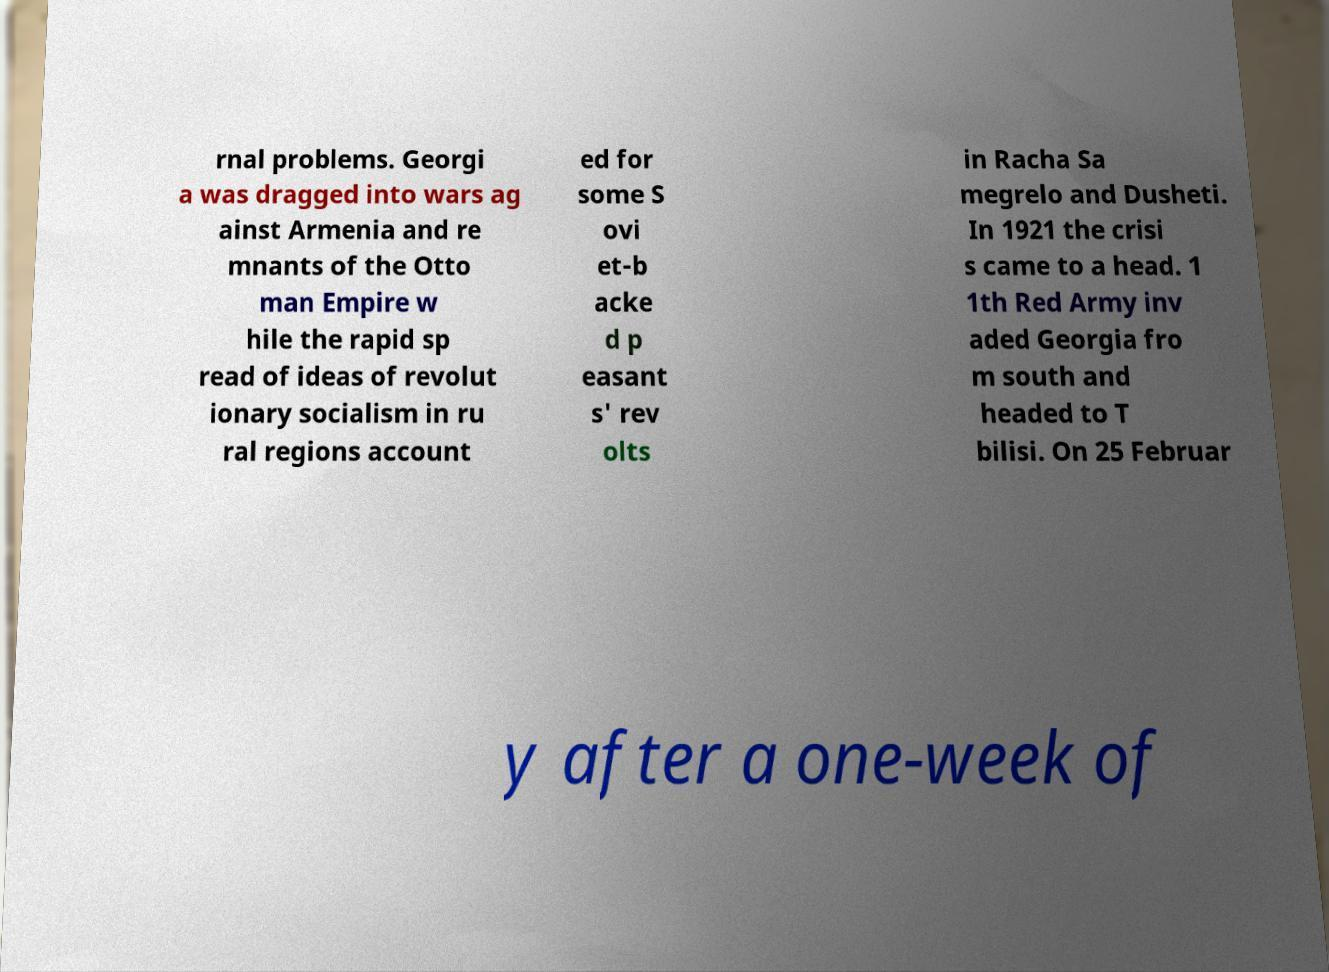Can you accurately transcribe the text from the provided image for me? rnal problems. Georgi a was dragged into wars ag ainst Armenia and re mnants of the Otto man Empire w hile the rapid sp read of ideas of revolut ionary socialism in ru ral regions account ed for some S ovi et-b acke d p easant s' rev olts in Racha Sa megrelo and Dusheti. In 1921 the crisi s came to a head. 1 1th Red Army inv aded Georgia fro m south and headed to T bilisi. On 25 Februar y after a one-week of 